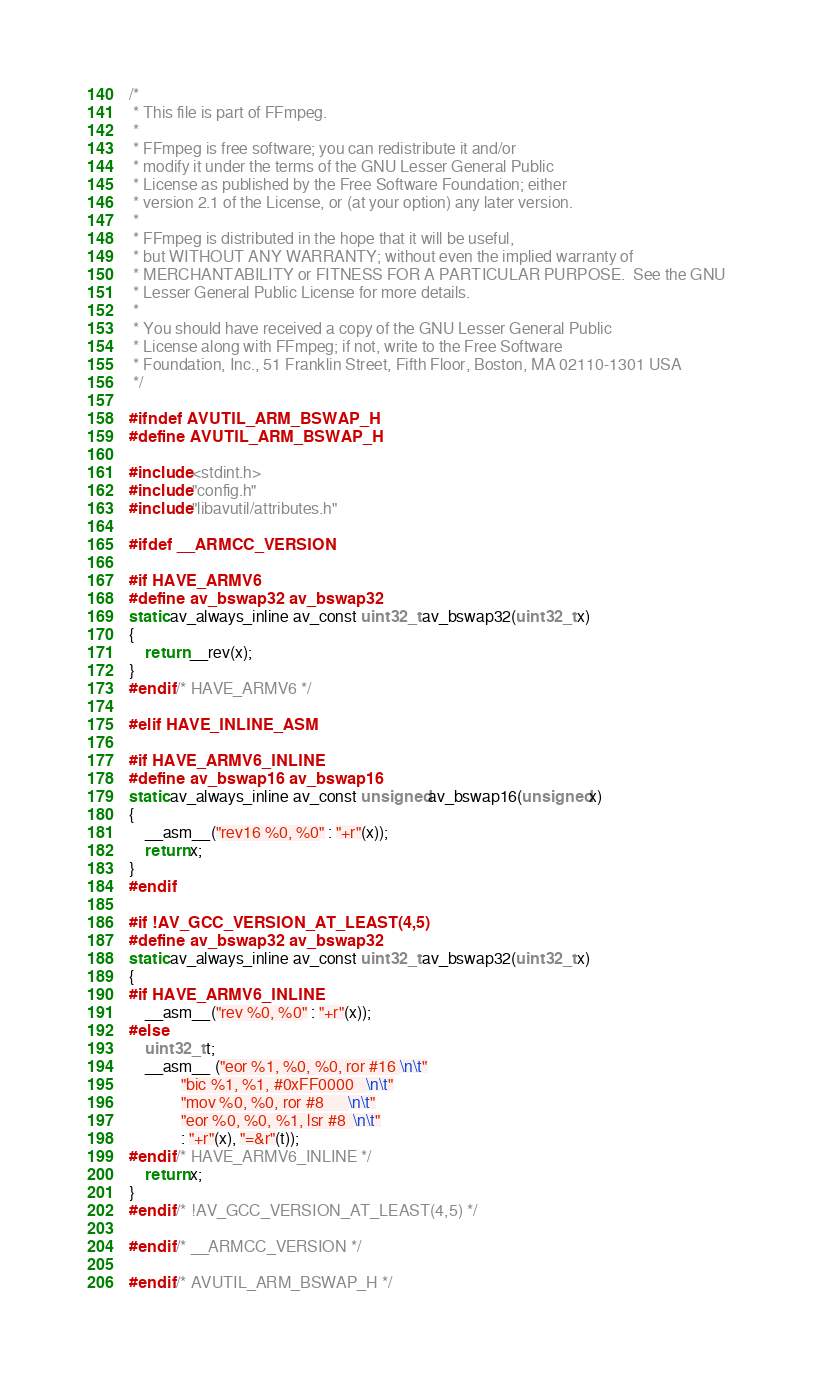<code> <loc_0><loc_0><loc_500><loc_500><_C_>/*
 * This file is part of FFmpeg.
 *
 * FFmpeg is free software; you can redistribute it and/or
 * modify it under the terms of the GNU Lesser General Public
 * License as published by the Free Software Foundation; either
 * version 2.1 of the License, or (at your option) any later version.
 *
 * FFmpeg is distributed in the hope that it will be useful,
 * but WITHOUT ANY WARRANTY; without even the implied warranty of
 * MERCHANTABILITY or FITNESS FOR A PARTICULAR PURPOSE.  See the GNU
 * Lesser General Public License for more details.
 *
 * You should have received a copy of the GNU Lesser General Public
 * License along with FFmpeg; if not, write to the Free Software
 * Foundation, Inc., 51 Franklin Street, Fifth Floor, Boston, MA 02110-1301 USA
 */

#ifndef AVUTIL_ARM_BSWAP_H
#define AVUTIL_ARM_BSWAP_H

#include <stdint.h>
#include "config.h"
#include "libavutil/attributes.h"

#ifdef __ARMCC_VERSION

#if HAVE_ARMV6
#define av_bswap32 av_bswap32
static av_always_inline av_const uint32_t av_bswap32(uint32_t x)
{
    return __rev(x);
}
#endif /* HAVE_ARMV6 */

#elif HAVE_INLINE_ASM

#if HAVE_ARMV6_INLINE
#define av_bswap16 av_bswap16
static av_always_inline av_const unsigned av_bswap16(unsigned x)
{
    __asm__("rev16 %0, %0" : "+r"(x));
    return x;
}
#endif

#if !AV_GCC_VERSION_AT_LEAST(4,5)
#define av_bswap32 av_bswap32
static av_always_inline av_const uint32_t av_bswap32(uint32_t x)
{
#if HAVE_ARMV6_INLINE
    __asm__("rev %0, %0" : "+r"(x));
#else
    uint32_t t;
    __asm__ ("eor %1, %0, %0, ror #16 \n\t"
             "bic %1, %1, #0xFF0000   \n\t"
             "mov %0, %0, ror #8      \n\t"
             "eor %0, %0, %1, lsr #8  \n\t"
             : "+r"(x), "=&r"(t));
#endif /* HAVE_ARMV6_INLINE */
    return x;
}
#endif /* !AV_GCC_VERSION_AT_LEAST(4,5) */

#endif /* __ARMCC_VERSION */

#endif /* AVUTIL_ARM_BSWAP_H */
</code> 